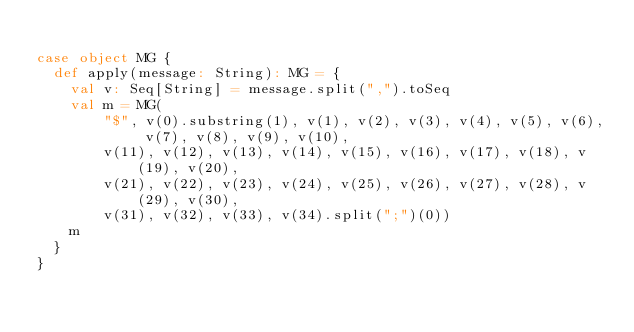Convert code to text. <code><loc_0><loc_0><loc_500><loc_500><_Scala_>
case object MG {
  def apply(message: String): MG = {
    val v: Seq[String] = message.split(",").toSeq
    val m = MG(
        "$", v(0).substring(1), v(1), v(2), v(3), v(4), v(5), v(6), v(7), v(8), v(9), v(10), 
        v(11), v(12), v(13), v(14), v(15), v(16), v(17), v(18), v(19), v(20), 
        v(21), v(22), v(23), v(24), v(25), v(26), v(27), v(28), v(29), v(30), 
        v(31), v(32), v(33), v(34).split(";")(0)) 
    m
  }
}
</code> 